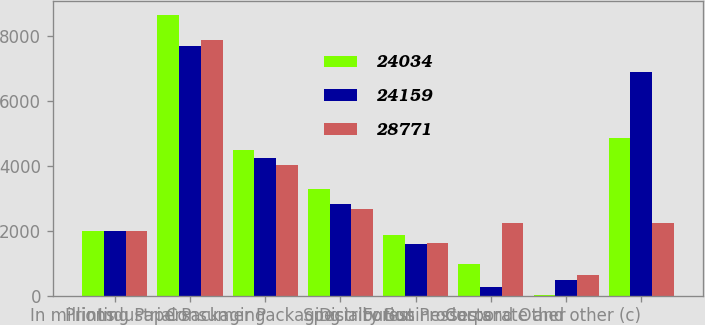Convert chart. <chart><loc_0><loc_0><loc_500><loc_500><stacked_bar_chart><ecel><fcel>In millions<fcel>Printing Papers<fcel>Industrial Packaging<fcel>Consumer Packaging<fcel>Distribution<fcel>Forest Products<fcel>Specialty Businesses and Other<fcel>Corporate and other (c)<nl><fcel>24034<fcel>2007<fcel>8650<fcel>4486<fcel>3285<fcel>1875<fcel>984<fcel>12<fcel>4867<nl><fcel>24159<fcel>2006<fcel>7699<fcel>4244<fcel>2840<fcel>1596<fcel>274<fcel>498<fcel>6883<nl><fcel>28771<fcel>2005<fcel>7893<fcel>4042<fcel>2673<fcel>1624<fcel>2234<fcel>652<fcel>2234<nl></chart> 